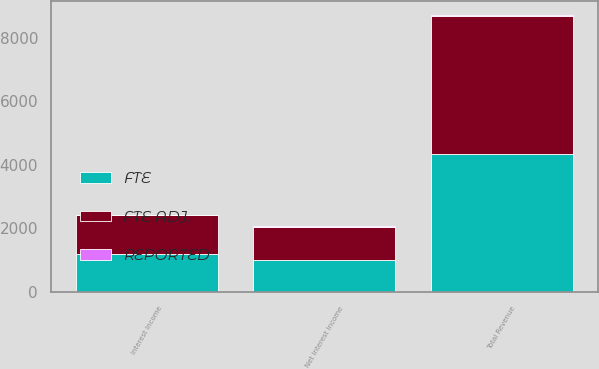Convert chart to OTSL. <chart><loc_0><loc_0><loc_500><loc_500><stacked_bar_chart><ecel><fcel>Interest Income<fcel>Net Interest Income<fcel>Total Revenue<nl><fcel>FTE<fcel>1186.9<fcel>1005.5<fcel>4331.2<nl><fcel>REPORTED<fcel>29.4<fcel>29.4<fcel>29.4<nl><fcel>FTE ADJ.<fcel>1216.3<fcel>1034.9<fcel>4360.6<nl></chart> 